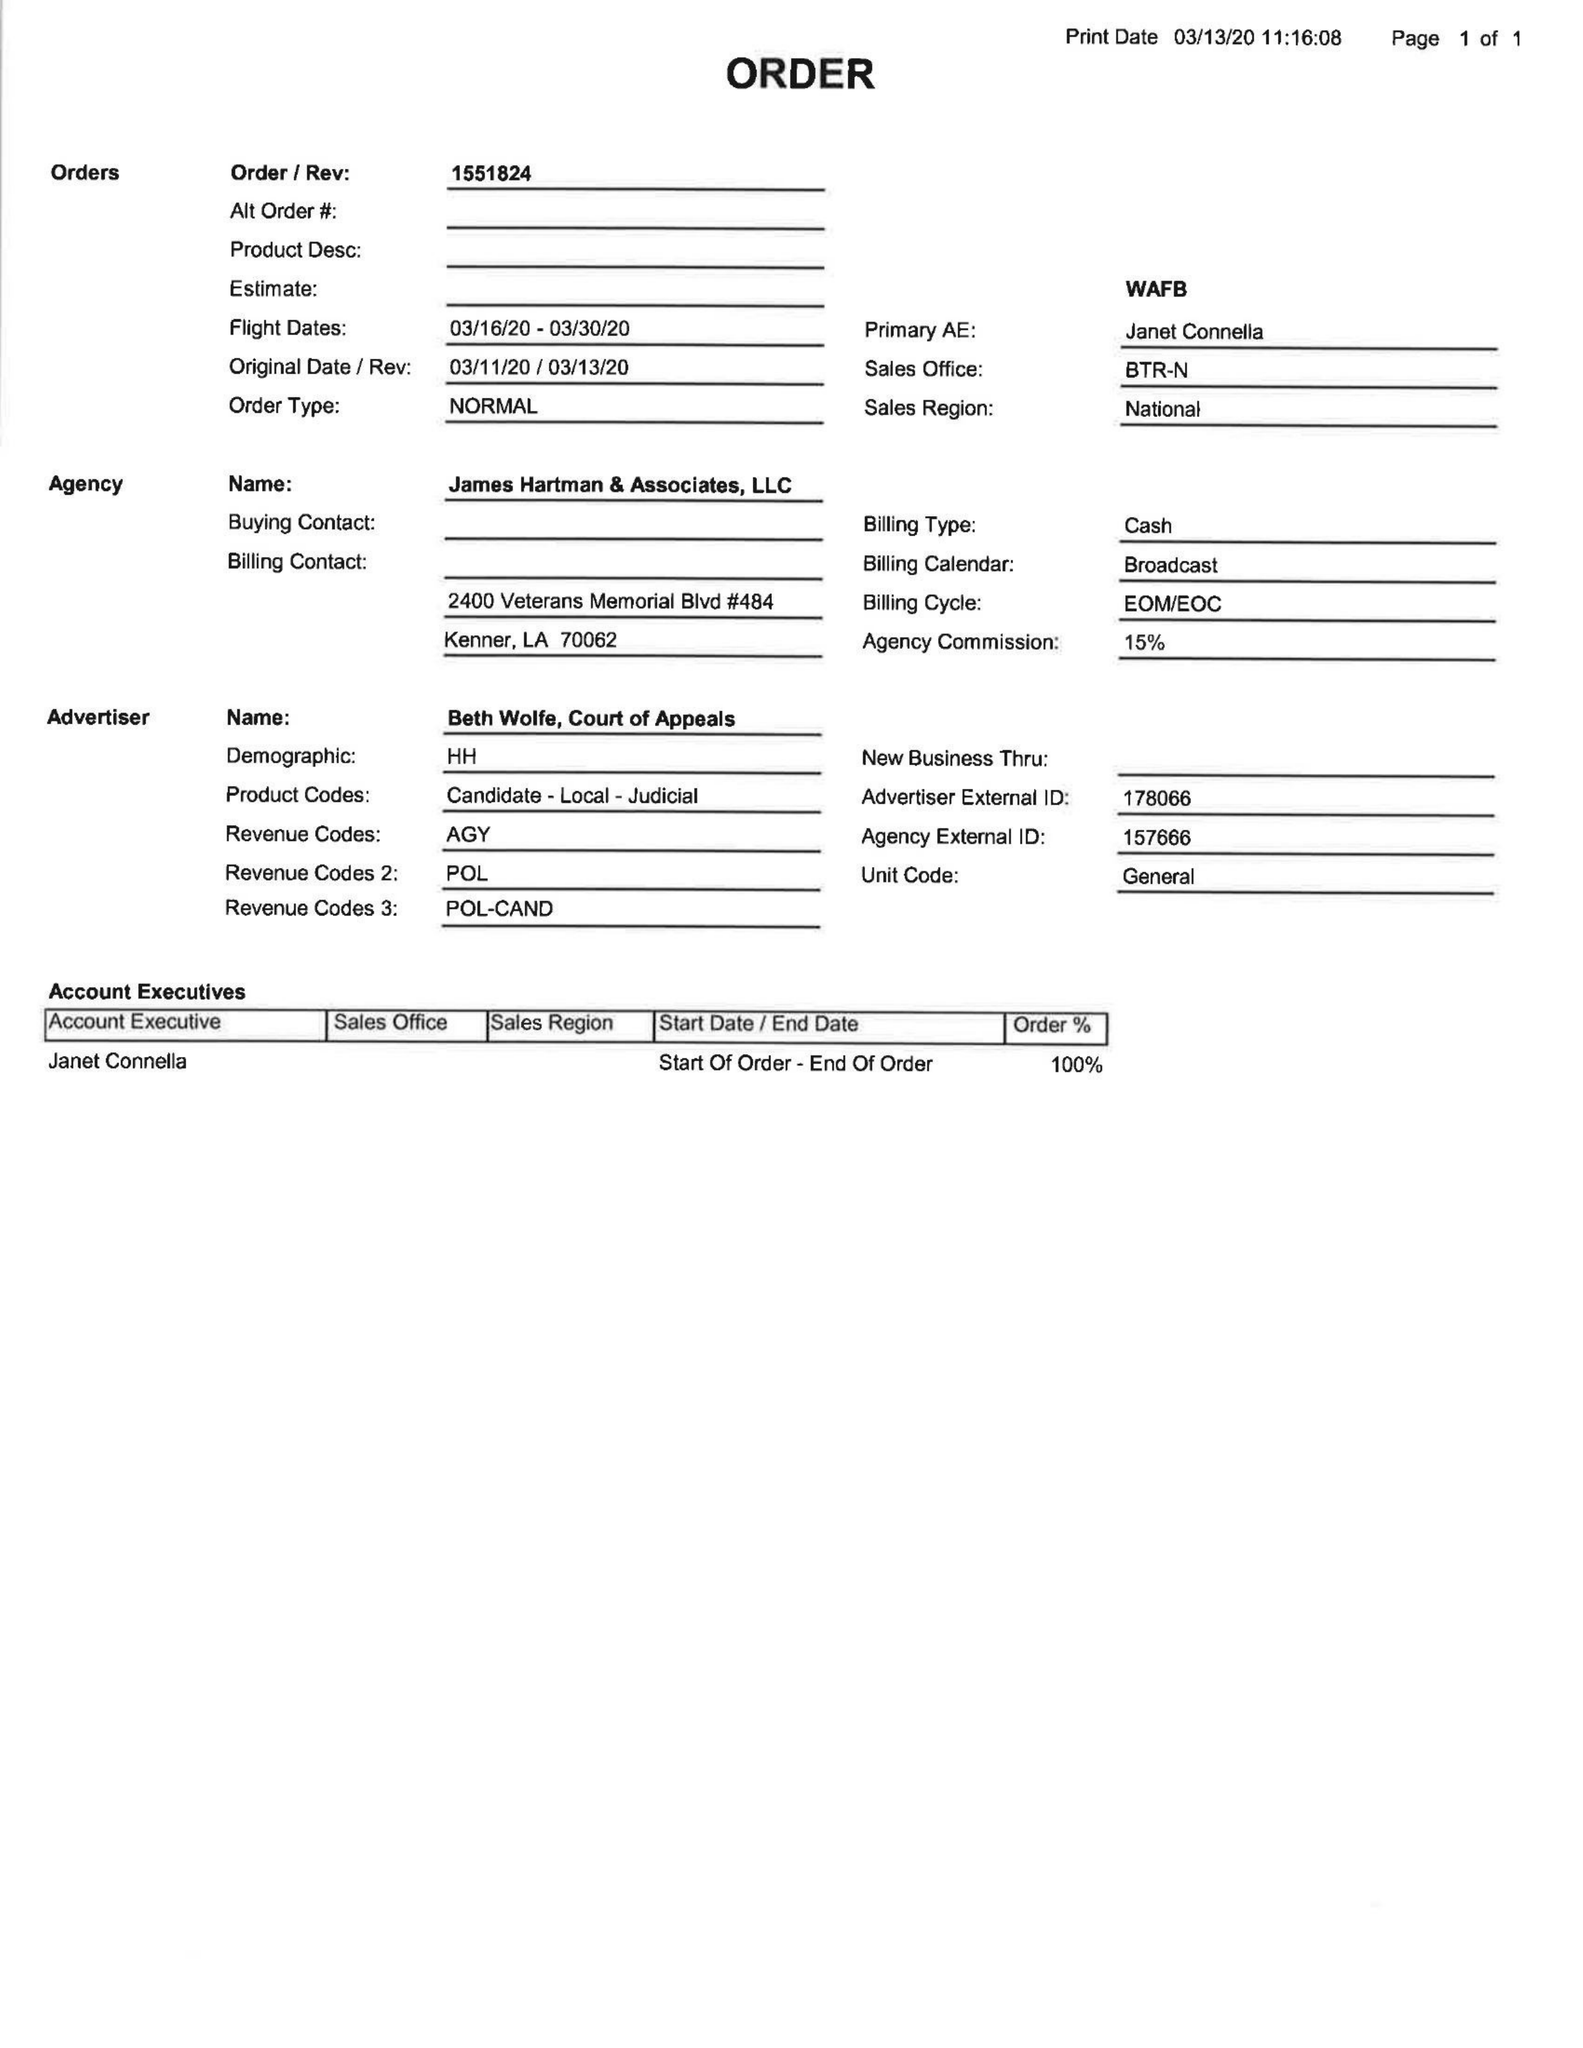What is the value for the advertiser?
Answer the question using a single word or phrase. BETH WOLFE, COURT OF APPEALS 